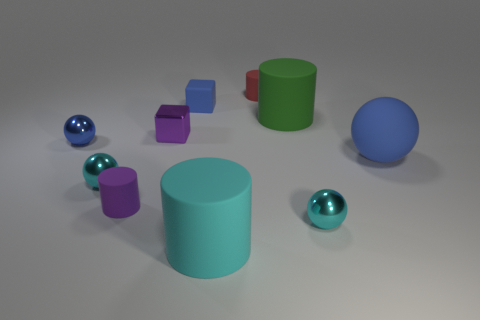What color is the shiny block?
Give a very brief answer. Purple. The cyan matte object that is left of the small cyan object that is right of the big matte cylinder that is on the left side of the small red thing is what shape?
Provide a short and direct response. Cylinder. What number of other objects are there of the same color as the big rubber sphere?
Provide a succinct answer. 2. Is the number of tiny purple blocks that are right of the small red rubber thing greater than the number of cyan things to the right of the big green thing?
Your answer should be very brief. No. There is a small purple block; are there any small purple cubes behind it?
Offer a very short reply. No. What material is the thing that is behind the matte ball and to the left of the tiny purple matte cylinder?
Offer a very short reply. Metal. There is another big matte thing that is the same shape as the cyan matte object; what is its color?
Your response must be concise. Green. Is there a tiny purple metallic object that is right of the block in front of the green thing?
Your response must be concise. No. How big is the green rubber cylinder?
Provide a short and direct response. Large. There is a blue object that is to the left of the green cylinder and in front of the green matte cylinder; what is its shape?
Ensure brevity in your answer.  Sphere. 